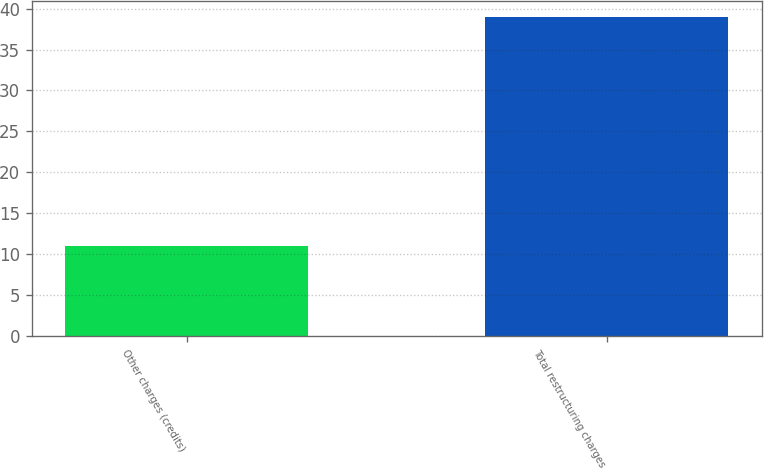<chart> <loc_0><loc_0><loc_500><loc_500><bar_chart><fcel>Other charges (credits)<fcel>Total restructuring charges<nl><fcel>11<fcel>39<nl></chart> 